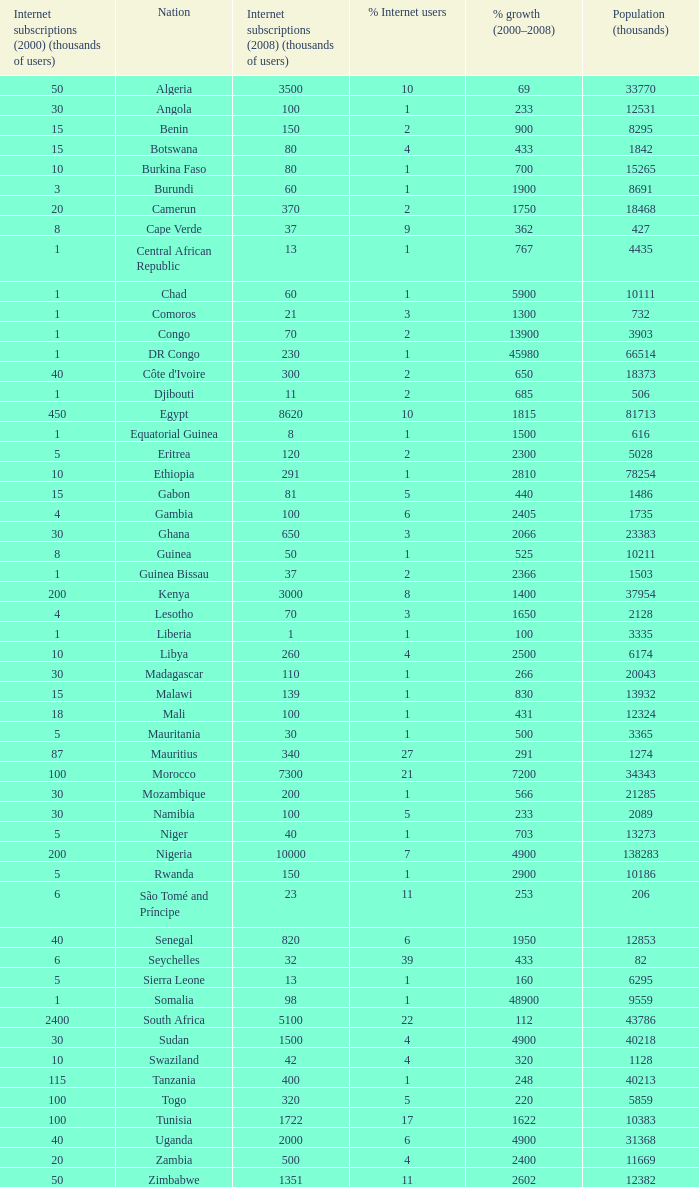What is the percentage of growth in 2000-2008 in ethiopia? 2810.0. 